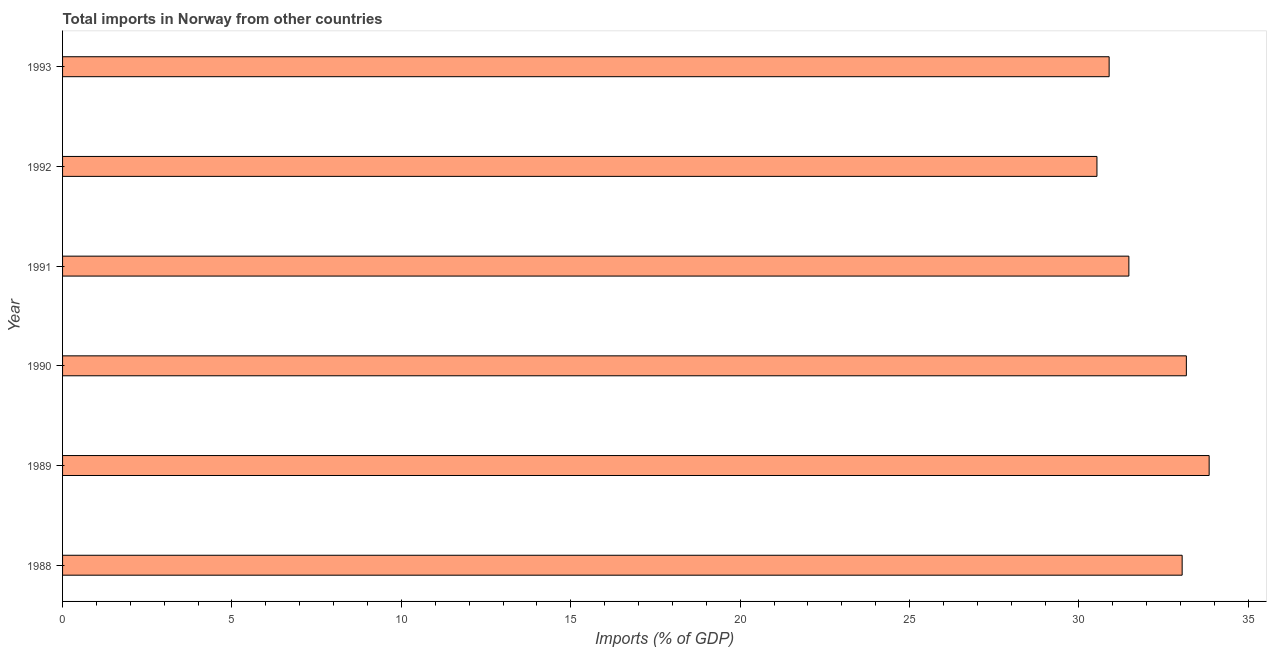Does the graph contain any zero values?
Provide a succinct answer. No. Does the graph contain grids?
Offer a very short reply. No. What is the title of the graph?
Offer a terse response. Total imports in Norway from other countries. What is the label or title of the X-axis?
Your response must be concise. Imports (% of GDP). What is the label or title of the Y-axis?
Your answer should be compact. Year. What is the total imports in 1989?
Keep it short and to the point. 33.84. Across all years, what is the maximum total imports?
Ensure brevity in your answer.  33.84. Across all years, what is the minimum total imports?
Keep it short and to the point. 30.53. In which year was the total imports maximum?
Your answer should be very brief. 1989. In which year was the total imports minimum?
Make the answer very short. 1992. What is the sum of the total imports?
Provide a short and direct response. 192.95. What is the difference between the total imports in 1988 and 1990?
Offer a terse response. -0.12. What is the average total imports per year?
Ensure brevity in your answer.  32.16. What is the median total imports?
Your response must be concise. 32.26. Do a majority of the years between 1988 and 1989 (inclusive) have total imports greater than 31 %?
Your response must be concise. Yes. What is the ratio of the total imports in 1989 to that in 1993?
Offer a terse response. 1.1. Is the difference between the total imports in 1988 and 1993 greater than the difference between any two years?
Offer a terse response. No. What is the difference between the highest and the second highest total imports?
Provide a succinct answer. 0.67. What is the difference between the highest and the lowest total imports?
Offer a terse response. 3.31. Are all the bars in the graph horizontal?
Ensure brevity in your answer.  Yes. How many years are there in the graph?
Provide a short and direct response. 6. What is the difference between two consecutive major ticks on the X-axis?
Give a very brief answer. 5. Are the values on the major ticks of X-axis written in scientific E-notation?
Offer a terse response. No. What is the Imports (% of GDP) in 1988?
Provide a short and direct response. 33.05. What is the Imports (% of GDP) in 1989?
Offer a very short reply. 33.84. What is the Imports (% of GDP) of 1990?
Provide a succinct answer. 33.17. What is the Imports (% of GDP) in 1991?
Provide a succinct answer. 31.47. What is the Imports (% of GDP) in 1992?
Your answer should be very brief. 30.53. What is the Imports (% of GDP) in 1993?
Ensure brevity in your answer.  30.89. What is the difference between the Imports (% of GDP) in 1988 and 1989?
Provide a short and direct response. -0.8. What is the difference between the Imports (% of GDP) in 1988 and 1990?
Provide a succinct answer. -0.12. What is the difference between the Imports (% of GDP) in 1988 and 1991?
Give a very brief answer. 1.57. What is the difference between the Imports (% of GDP) in 1988 and 1992?
Ensure brevity in your answer.  2.51. What is the difference between the Imports (% of GDP) in 1988 and 1993?
Provide a short and direct response. 2.16. What is the difference between the Imports (% of GDP) in 1989 and 1990?
Provide a short and direct response. 0.67. What is the difference between the Imports (% of GDP) in 1989 and 1991?
Give a very brief answer. 2.37. What is the difference between the Imports (% of GDP) in 1989 and 1992?
Give a very brief answer. 3.31. What is the difference between the Imports (% of GDP) in 1989 and 1993?
Make the answer very short. 2.95. What is the difference between the Imports (% of GDP) in 1990 and 1991?
Give a very brief answer. 1.7. What is the difference between the Imports (% of GDP) in 1990 and 1992?
Provide a succinct answer. 2.64. What is the difference between the Imports (% of GDP) in 1990 and 1993?
Your response must be concise. 2.28. What is the difference between the Imports (% of GDP) in 1991 and 1992?
Give a very brief answer. 0.94. What is the difference between the Imports (% of GDP) in 1991 and 1993?
Ensure brevity in your answer.  0.58. What is the difference between the Imports (% of GDP) in 1992 and 1993?
Give a very brief answer. -0.36. What is the ratio of the Imports (% of GDP) in 1988 to that in 1990?
Offer a very short reply. 1. What is the ratio of the Imports (% of GDP) in 1988 to that in 1991?
Provide a short and direct response. 1.05. What is the ratio of the Imports (% of GDP) in 1988 to that in 1992?
Make the answer very short. 1.08. What is the ratio of the Imports (% of GDP) in 1988 to that in 1993?
Offer a terse response. 1.07. What is the ratio of the Imports (% of GDP) in 1989 to that in 1991?
Your answer should be compact. 1.07. What is the ratio of the Imports (% of GDP) in 1989 to that in 1992?
Give a very brief answer. 1.11. What is the ratio of the Imports (% of GDP) in 1989 to that in 1993?
Keep it short and to the point. 1.1. What is the ratio of the Imports (% of GDP) in 1990 to that in 1991?
Offer a very short reply. 1.05. What is the ratio of the Imports (% of GDP) in 1990 to that in 1992?
Provide a succinct answer. 1.09. What is the ratio of the Imports (% of GDP) in 1990 to that in 1993?
Provide a succinct answer. 1.07. What is the ratio of the Imports (% of GDP) in 1991 to that in 1992?
Your answer should be compact. 1.03. What is the ratio of the Imports (% of GDP) in 1991 to that in 1993?
Your answer should be compact. 1.02. 